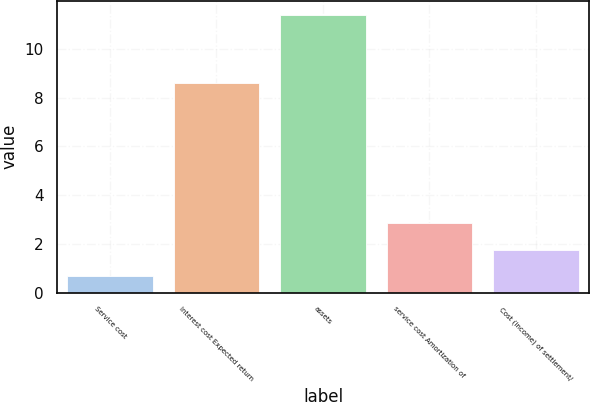Convert chart. <chart><loc_0><loc_0><loc_500><loc_500><bar_chart><fcel>Service cost<fcel>Interest cost Expected return<fcel>assets<fcel>service cost Amortization of<fcel>Cost (income) of settlement/<nl><fcel>0.7<fcel>8.6<fcel>11.4<fcel>2.84<fcel>1.77<nl></chart> 